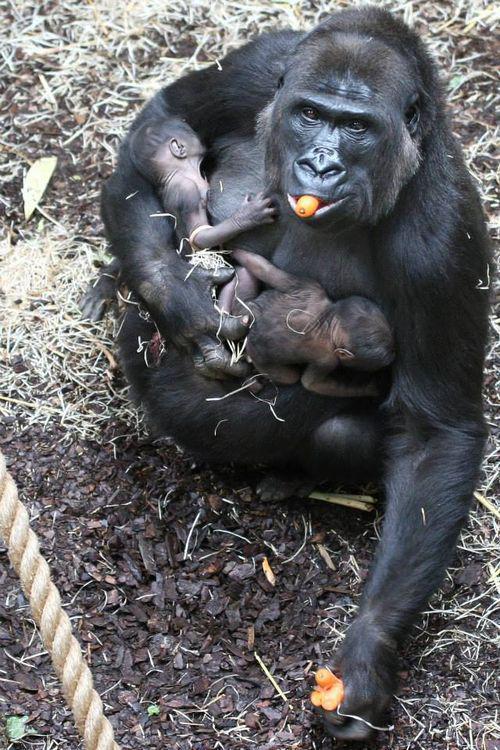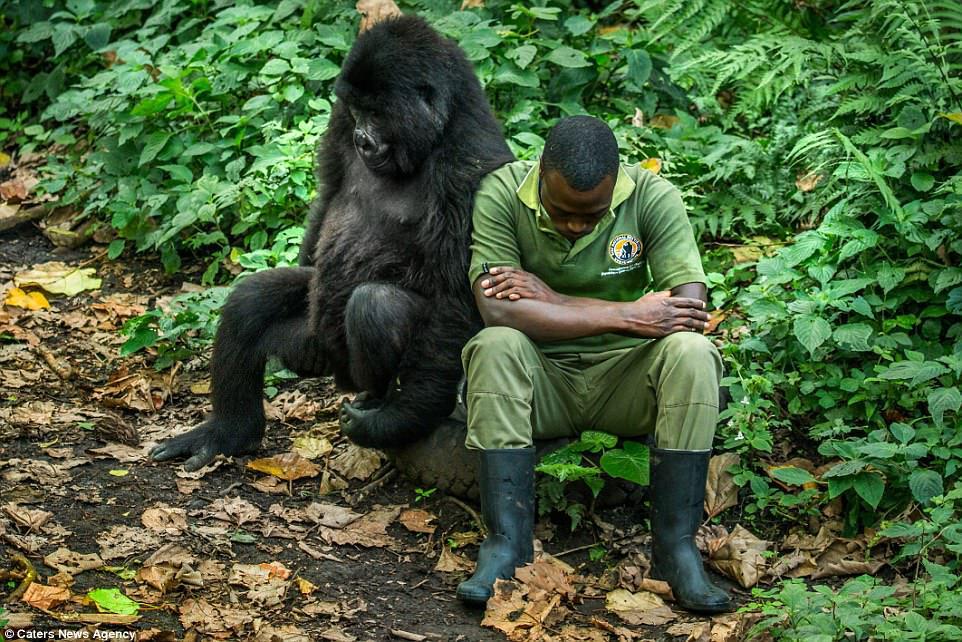The first image is the image on the left, the second image is the image on the right. For the images shown, is this caption "A gorilla is holding a baby gorilla" true? Answer yes or no. Yes. The first image is the image on the left, the second image is the image on the right. Assess this claim about the two images: "One image shows a forward-gazing gorilla clutching at least one infant gorilla to its chest.". Correct or not? Answer yes or no. Yes. 